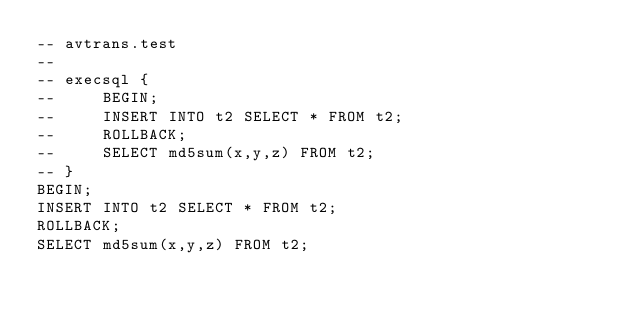Convert code to text. <code><loc_0><loc_0><loc_500><loc_500><_SQL_>-- avtrans.test
-- 
-- execsql {
--     BEGIN;
--     INSERT INTO t2 SELECT * FROM t2;
--     ROLLBACK;
--     SELECT md5sum(x,y,z) FROM t2;
-- }
BEGIN;
INSERT INTO t2 SELECT * FROM t2;
ROLLBACK;
SELECT md5sum(x,y,z) FROM t2;</code> 